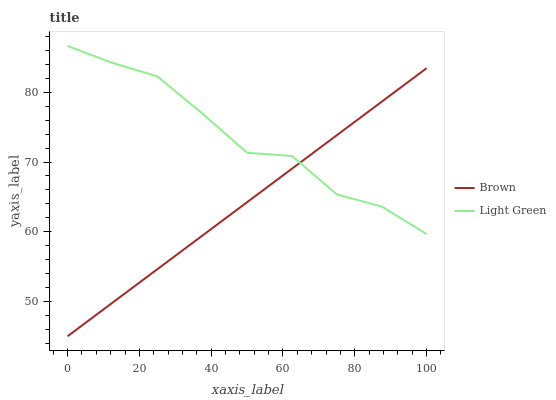Does Light Green have the minimum area under the curve?
Answer yes or no. No. Is Light Green the smoothest?
Answer yes or no. No. Does Light Green have the lowest value?
Answer yes or no. No. 